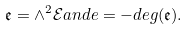Convert formula to latex. <formula><loc_0><loc_0><loc_500><loc_500>\mathfrak { e } = \wedge ^ { 2 } \mathcal { E } a n d e = - d e g ( \mathfrak { e } ) .</formula> 